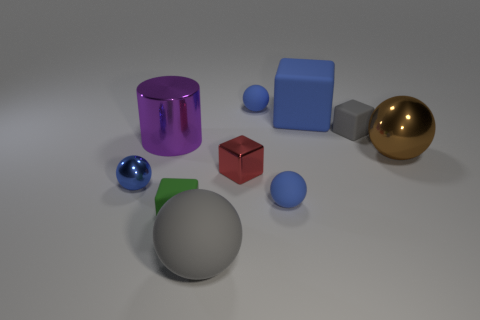How many blue balls must be subtracted to get 1 blue balls? 2 Subtract all gray cylinders. How many blue spheres are left? 3 Subtract 1 balls. How many balls are left? 4 Subtract all brown spheres. How many spheres are left? 4 Subtract all purple spheres. Subtract all blue cubes. How many spheres are left? 5 Subtract all blocks. How many objects are left? 6 Subtract 0 red balls. How many objects are left? 10 Subtract all tiny metallic objects. Subtract all blue matte objects. How many objects are left? 5 Add 2 shiny cylinders. How many shiny cylinders are left? 3 Add 2 large rubber spheres. How many large rubber spheres exist? 3 